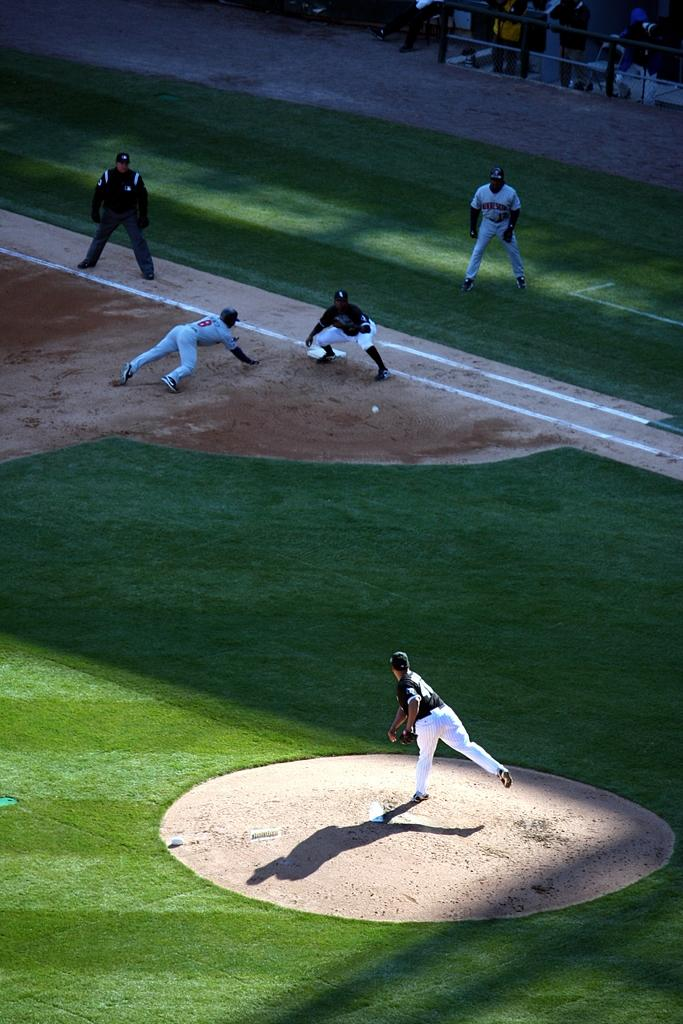What object can be seen in the image? There is a ball in the image. How many people are on the ground in the image? There are five people on the ground in the image. What type of vegetation is visible in the background of the image? There is grass visible in the background of the image. What can be seen in the background of the image besides the grass? There is a fence and other people in the background of the image. What else is present in the background of the image? There are some objects in the background of the image. What type of punishment is being administered to the ball in the image? There is no punishment being administered to the ball in the image; it is simply a ball. Can you describe the argument taking place between the ball and the fence in the image? There is no argument between the ball and the fence in the image; they are separate objects. 